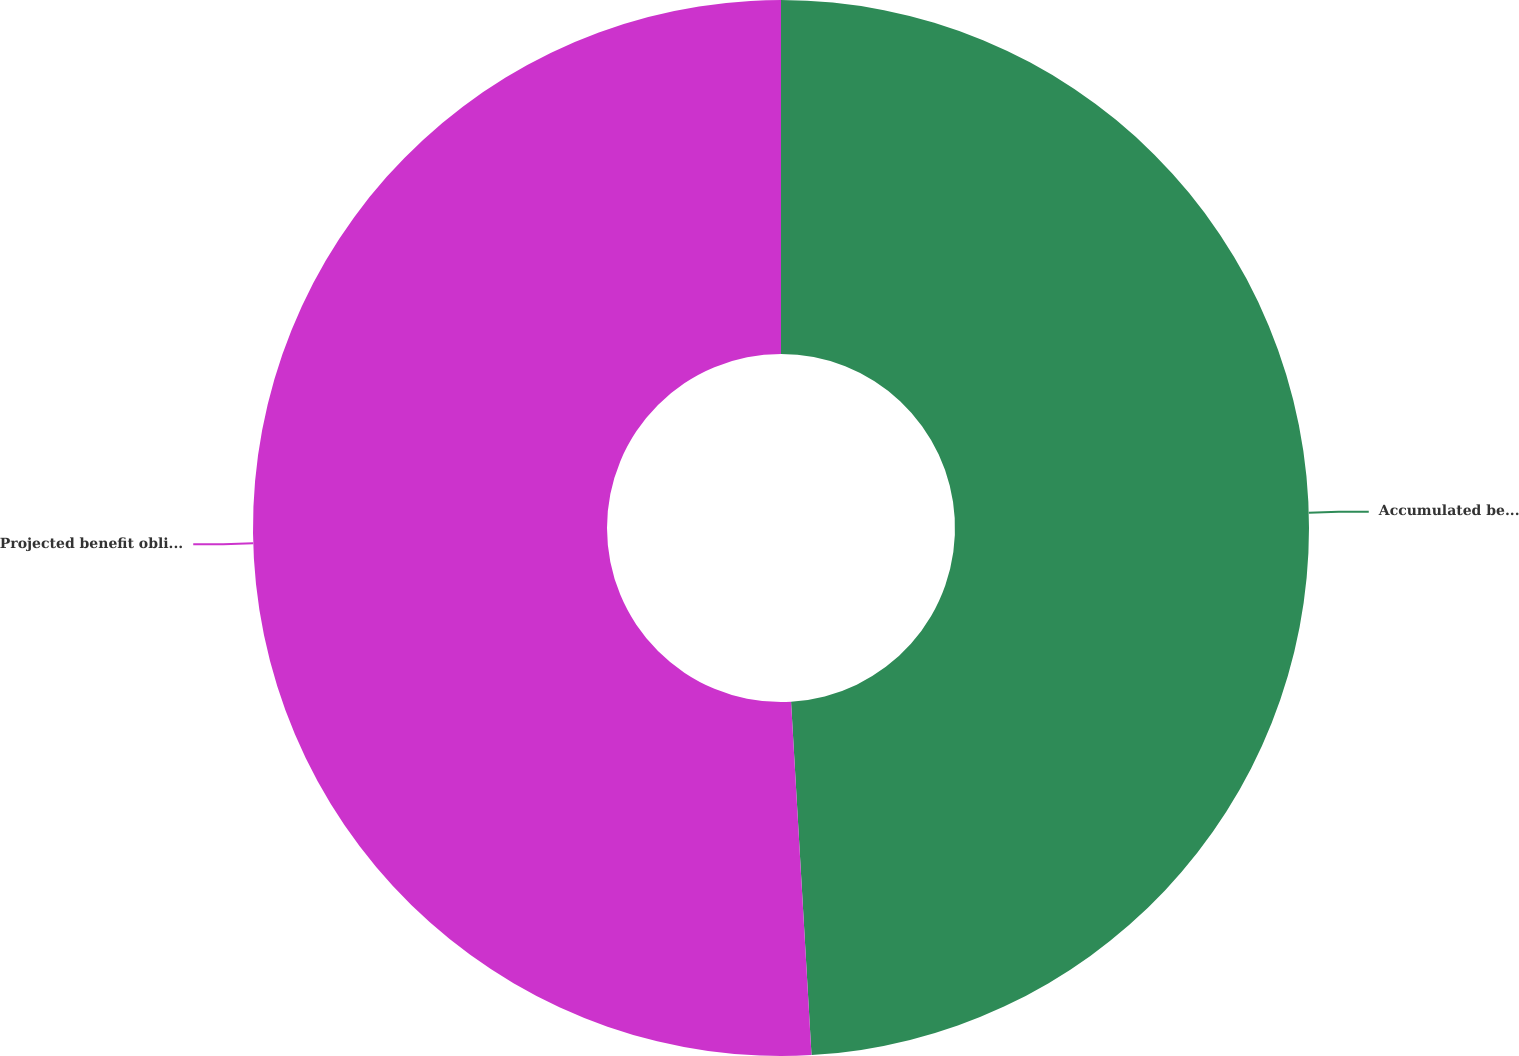Convert chart. <chart><loc_0><loc_0><loc_500><loc_500><pie_chart><fcel>Accumulated benefit obligation<fcel>Projected benefit obligation<nl><fcel>49.08%<fcel>50.92%<nl></chart> 